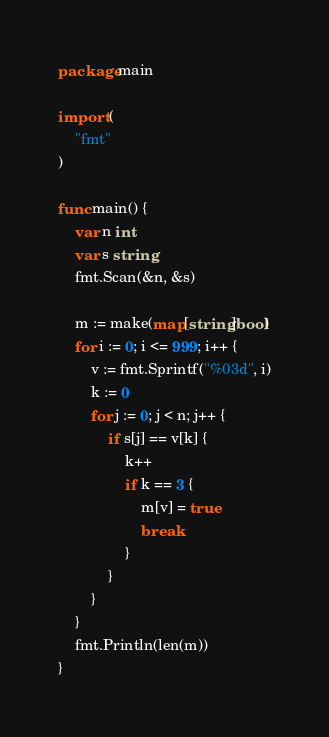Convert code to text. <code><loc_0><loc_0><loc_500><loc_500><_Go_>package main

import (
	"fmt"
)

func main() {
	var n int
	var s string
	fmt.Scan(&n, &s)

	m := make(map[string]bool)
	for i := 0; i <= 999; i++ {
		v := fmt.Sprintf("%03d", i)
		k := 0
		for j := 0; j < n; j++ {
			if s[j] == v[k] {
				k++
				if k == 3 {
					m[v] = true
					break
				}
			}
		}
	}
	fmt.Println(len(m))
}
</code> 